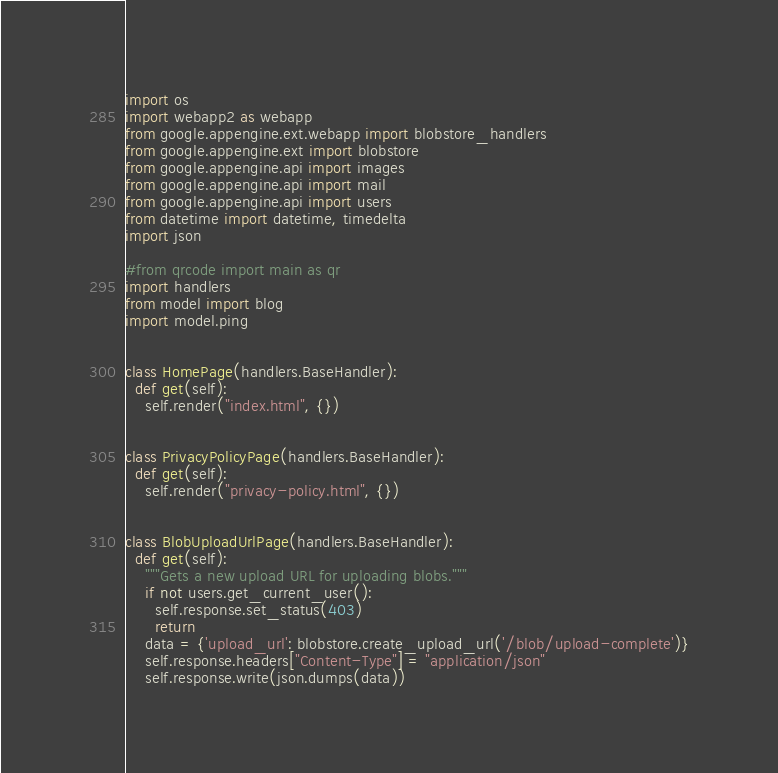Convert code to text. <code><loc_0><loc_0><loc_500><loc_500><_Python_>
import os
import webapp2 as webapp
from google.appengine.ext.webapp import blobstore_handlers
from google.appengine.ext import blobstore
from google.appengine.api import images
from google.appengine.api import mail
from google.appengine.api import users
from datetime import datetime, timedelta
import json

#from qrcode import main as qr
import handlers
from model import blog
import model.ping


class HomePage(handlers.BaseHandler):
  def get(self):
    self.render("index.html", {})


class PrivacyPolicyPage(handlers.BaseHandler):
  def get(self):
    self.render("privacy-policy.html", {})


class BlobUploadUrlPage(handlers.BaseHandler):
  def get(self):
    """Gets a new upload URL for uploading blobs."""
    if not users.get_current_user():
      self.response.set_status(403)
      return
    data = {'upload_url': blobstore.create_upload_url('/blob/upload-complete')}
    self.response.headers["Content-Type"] = "application/json"
    self.response.write(json.dumps(data))    

</code> 